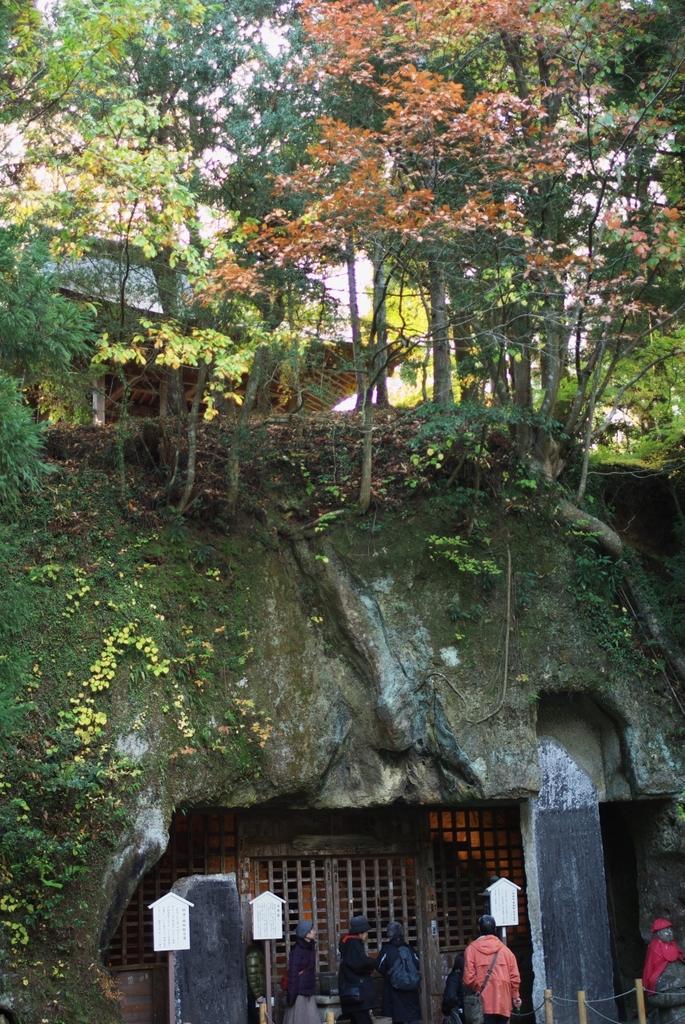Please provide a concise description of this image. In the center of the image a cave is present. At the bottom of the image we can see door, boards, some persons are there. At the top of the image some trees and hut, sky are present. 